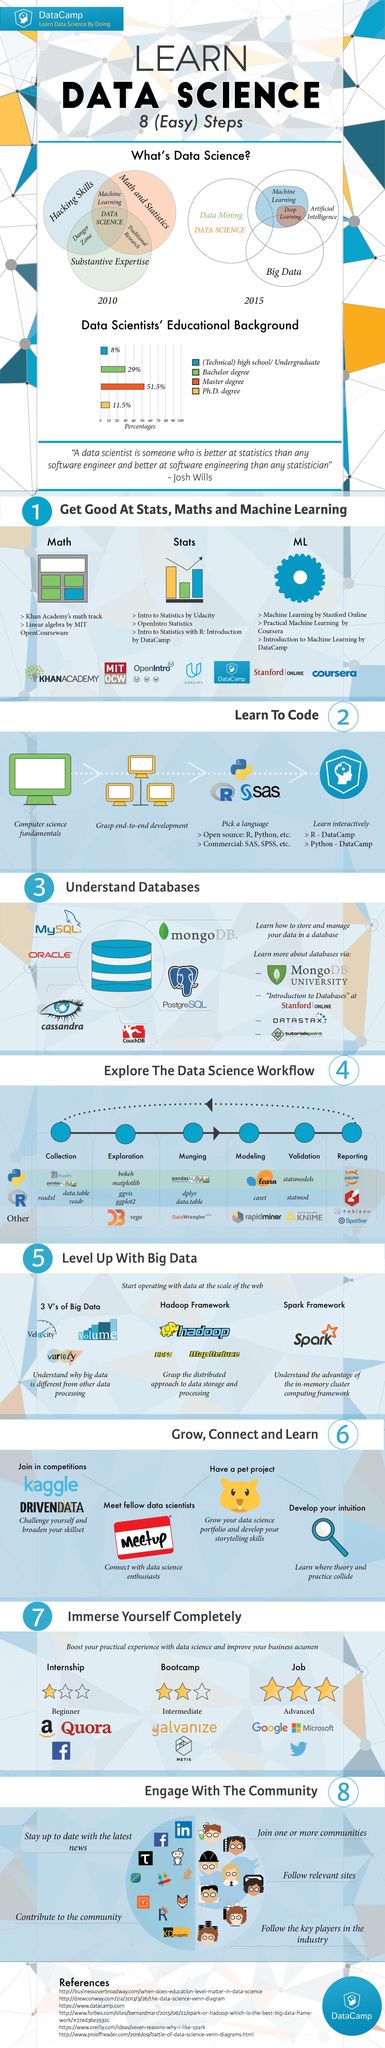Mention a couple of crucial points in this snapshot. Data science is the intersection of mathematics, statistics, hacking skills, and substantive expertise, characterized by the practical application of statistical and computational techniques to solve complex problems and extract meaningful insights from data. The specific number of steps involved in the data science workflow is 6. Artificial Intelligence encompasses a range of disciplines, including machine learning and deep learning, that enable computers to perform tasks typically requiring human intelligence, such as recognizing patterns, making decisions, and solving problems. It is commonly known that the highest degree held by data scientists is a Master's degree. Machine learning requires essential skills in hacking, mathematics, and statistics to be successful. 